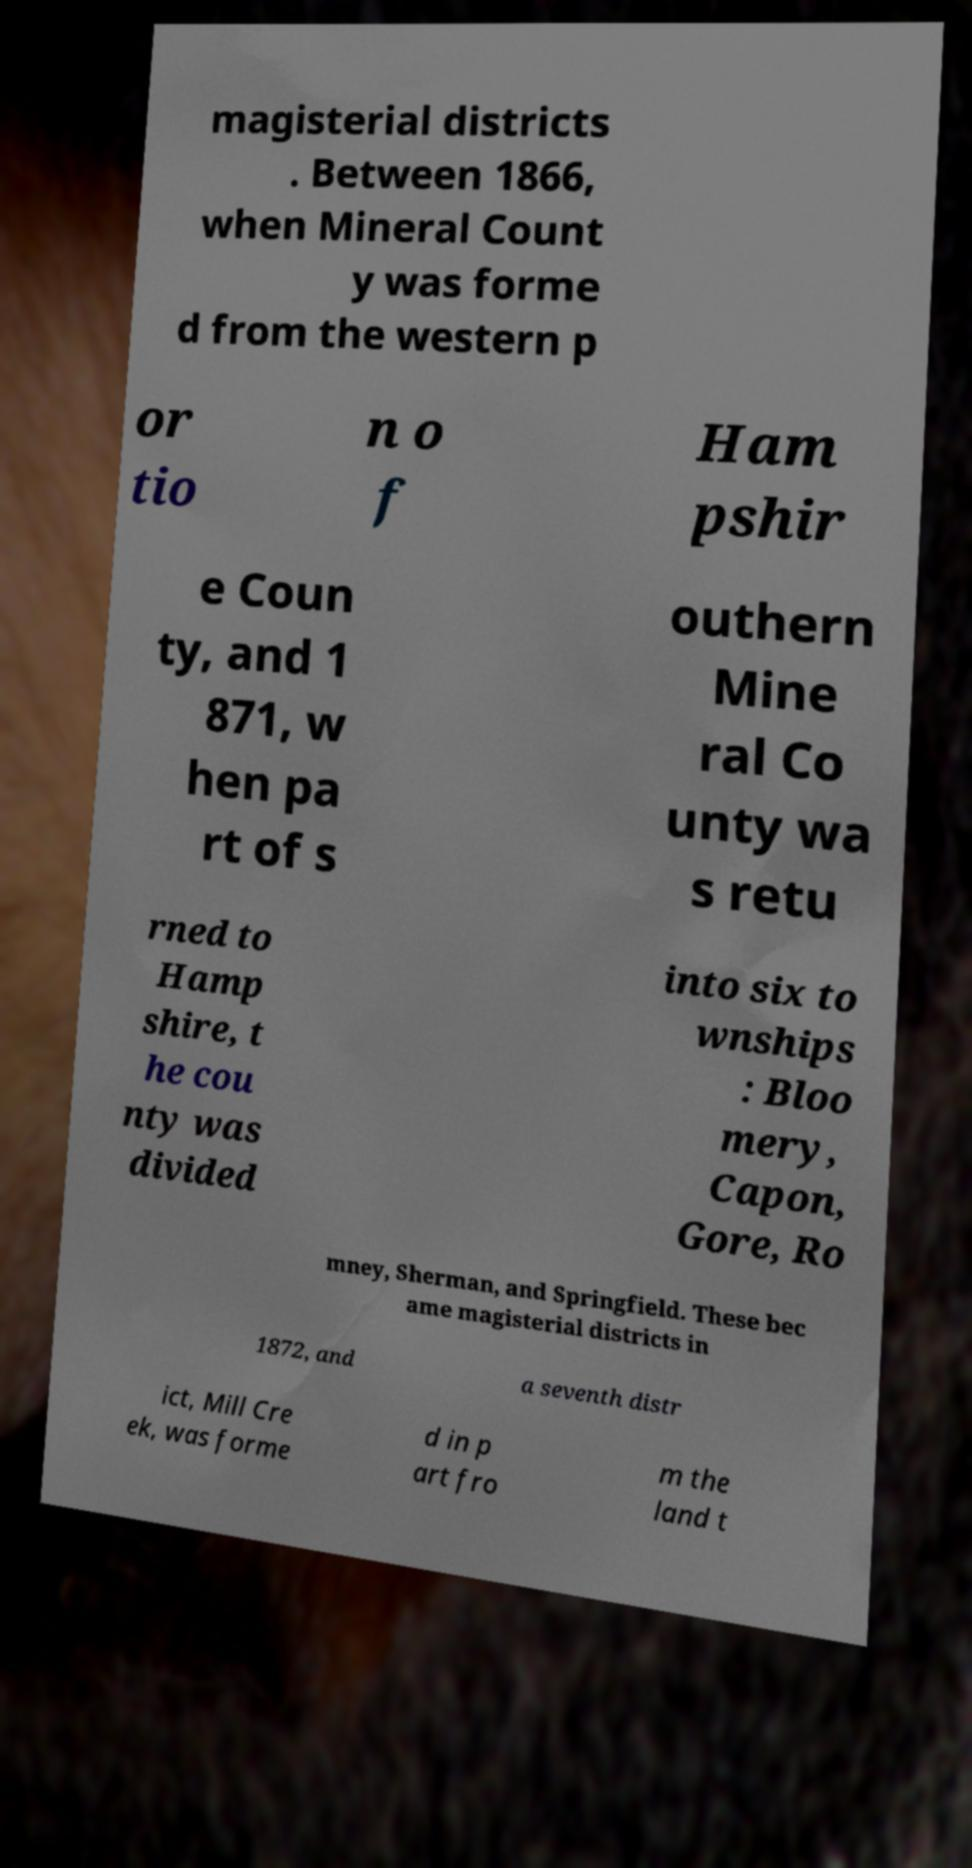Could you assist in decoding the text presented in this image and type it out clearly? magisterial districts . Between 1866, when Mineral Count y was forme d from the western p or tio n o f Ham pshir e Coun ty, and 1 871, w hen pa rt of s outhern Mine ral Co unty wa s retu rned to Hamp shire, t he cou nty was divided into six to wnships : Bloo mery, Capon, Gore, Ro mney, Sherman, and Springfield. These bec ame magisterial districts in 1872, and a seventh distr ict, Mill Cre ek, was forme d in p art fro m the land t 